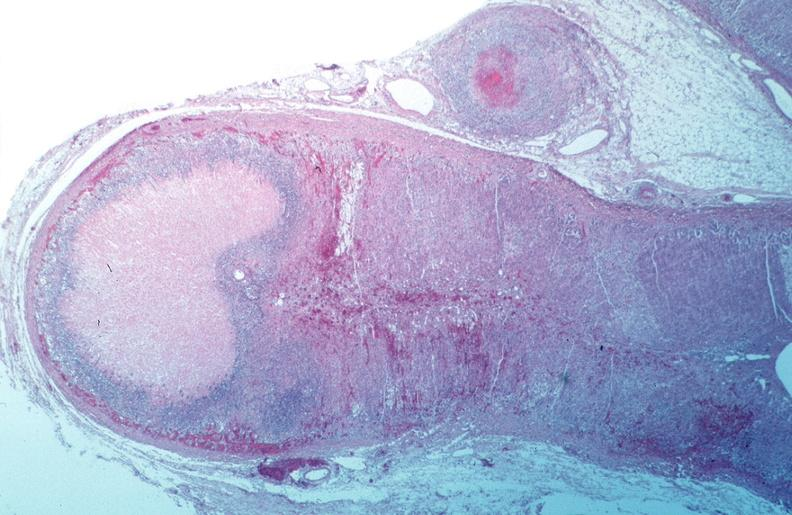does marked show vasculitis, polyarteritis nodosa?
Answer the question using a single word or phrase. No 